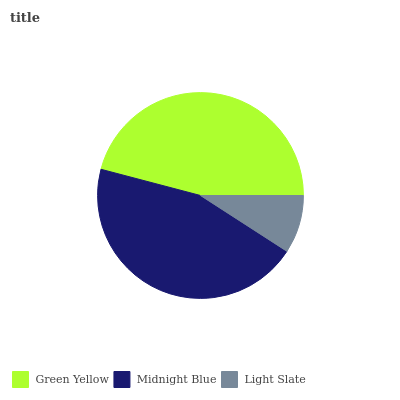Is Light Slate the minimum?
Answer yes or no. Yes. Is Green Yellow the maximum?
Answer yes or no. Yes. Is Midnight Blue the minimum?
Answer yes or no. No. Is Midnight Blue the maximum?
Answer yes or no. No. Is Green Yellow greater than Midnight Blue?
Answer yes or no. Yes. Is Midnight Blue less than Green Yellow?
Answer yes or no. Yes. Is Midnight Blue greater than Green Yellow?
Answer yes or no. No. Is Green Yellow less than Midnight Blue?
Answer yes or no. No. Is Midnight Blue the high median?
Answer yes or no. Yes. Is Midnight Blue the low median?
Answer yes or no. Yes. Is Green Yellow the high median?
Answer yes or no. No. Is Green Yellow the low median?
Answer yes or no. No. 